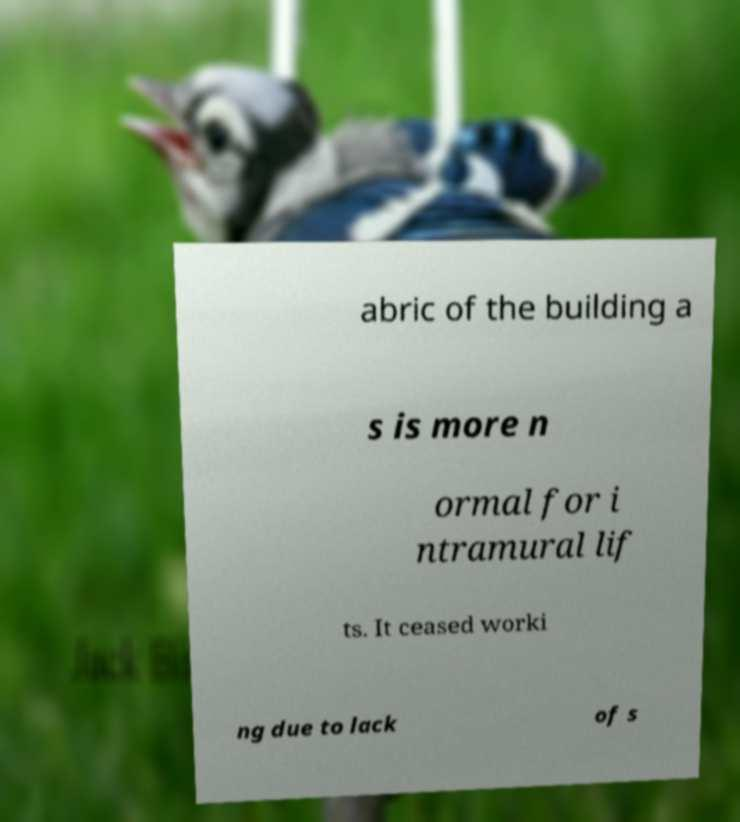What messages or text are displayed in this image? I need them in a readable, typed format. abric of the building a s is more n ormal for i ntramural lif ts. It ceased worki ng due to lack of s 